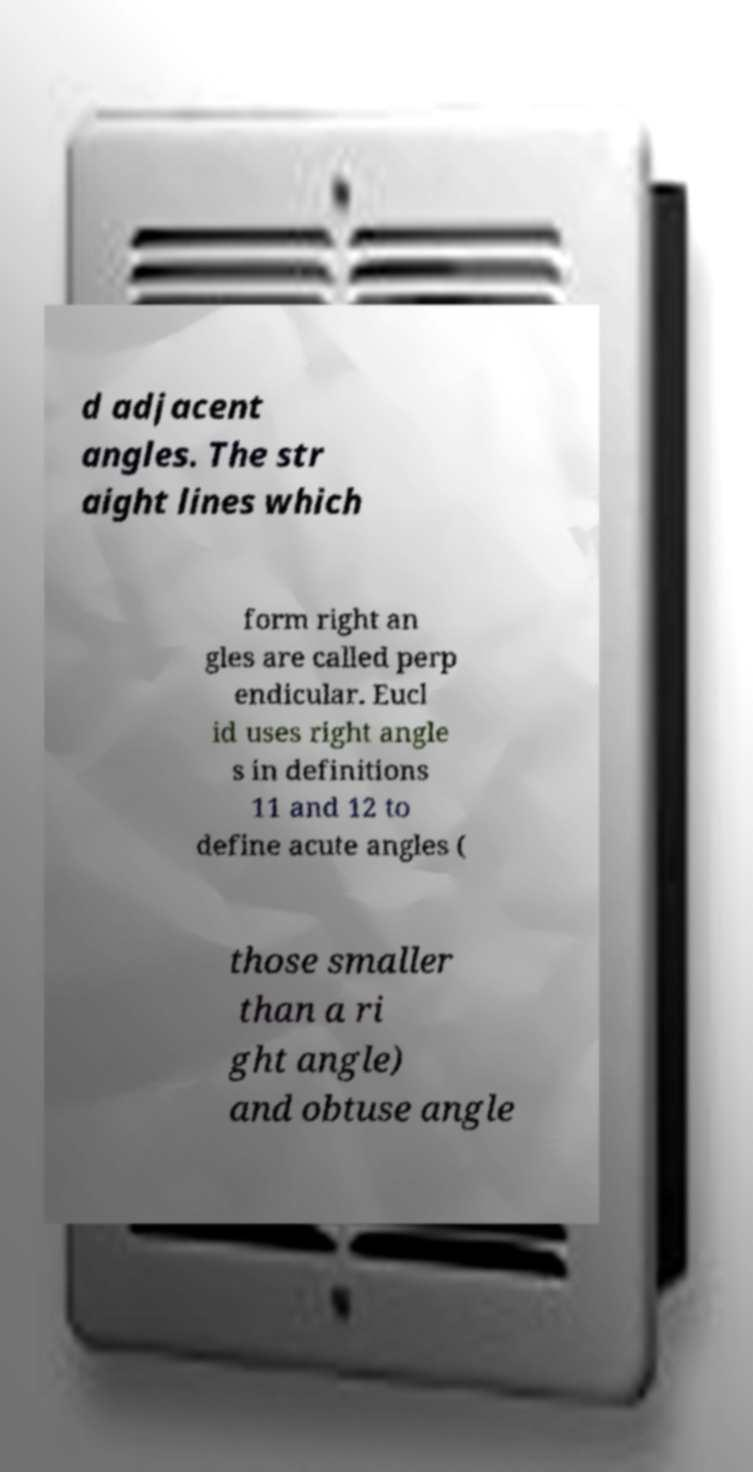For documentation purposes, I need the text within this image transcribed. Could you provide that? d adjacent angles. The str aight lines which form right an gles are called perp endicular. Eucl id uses right angle s in definitions 11 and 12 to define acute angles ( those smaller than a ri ght angle) and obtuse angle 